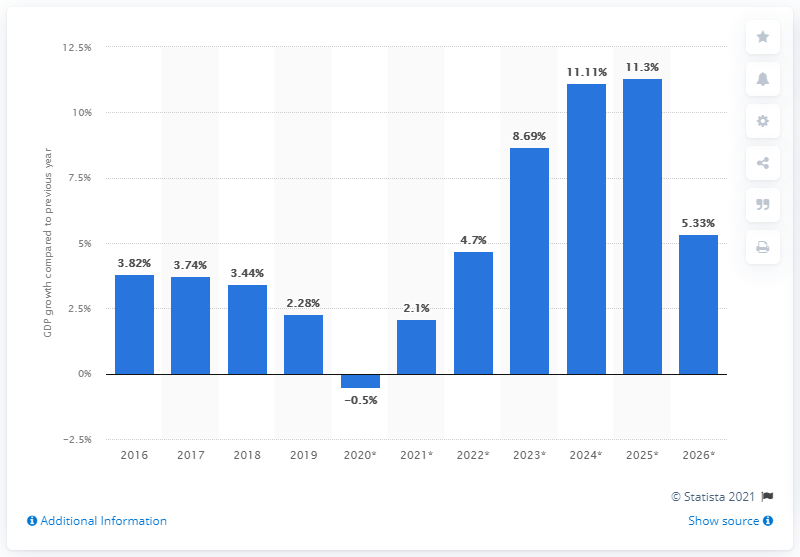Outline some significant characteristics in this image. According to the information provided, Mozambique's real gross domestic product (GDP) increased by 2.28% in 2019. 